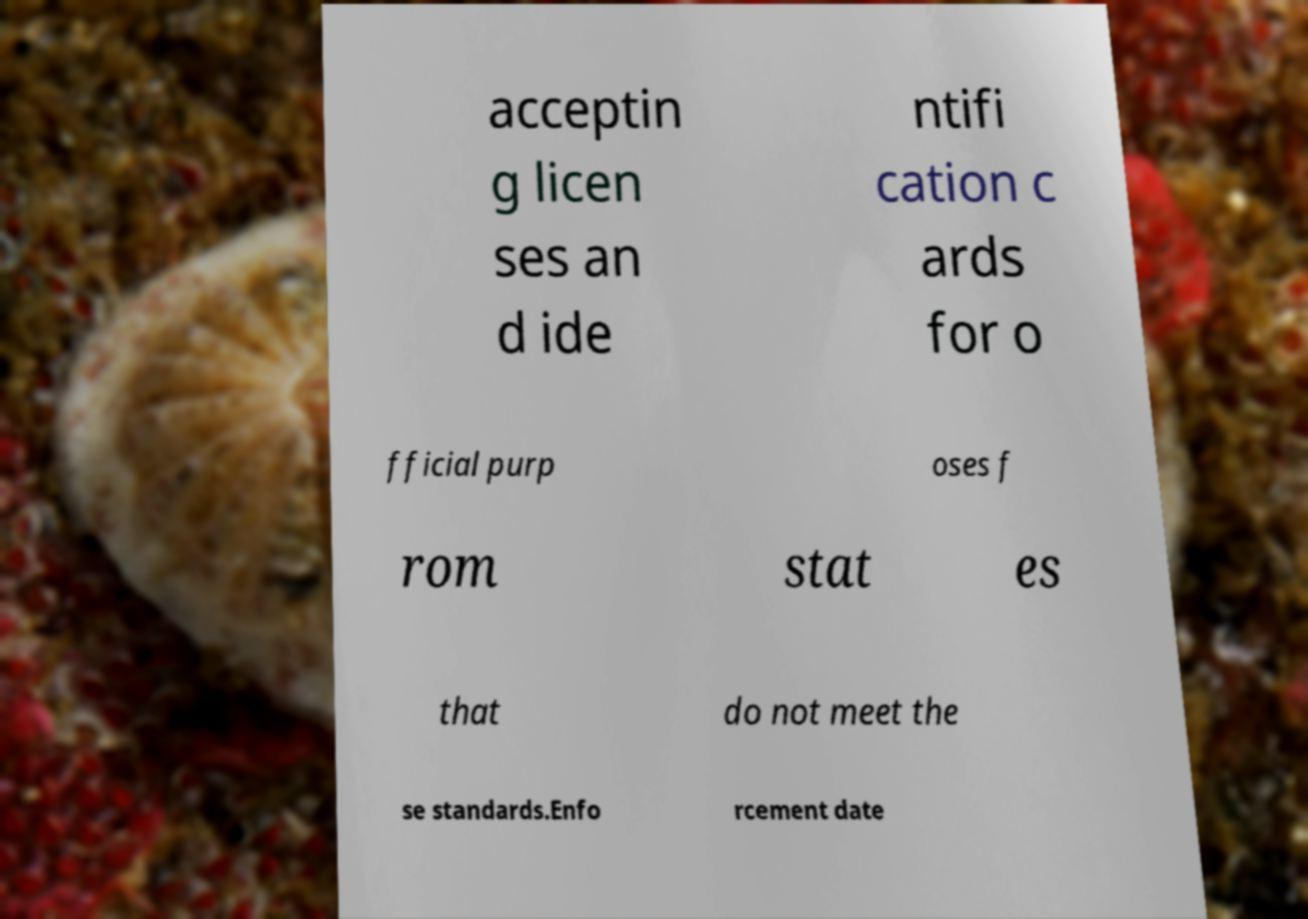What messages or text are displayed in this image? I need them in a readable, typed format. acceptin g licen ses an d ide ntifi cation c ards for o fficial purp oses f rom stat es that do not meet the se standards.Enfo rcement date 